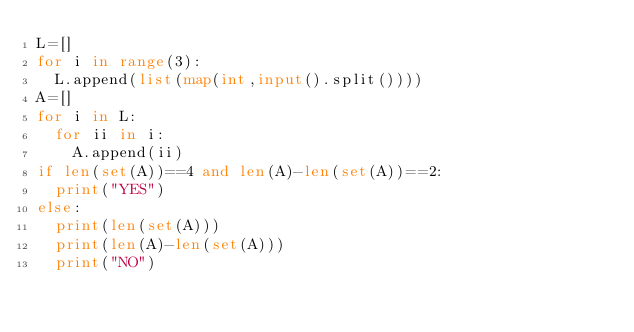Convert code to text. <code><loc_0><loc_0><loc_500><loc_500><_Python_>L=[]
for i in range(3):
  L.append(list(map(int,input().split())))
A=[]
for i in L:
  for ii in i:
    A.append(ii)
if len(set(A))==4 and len(A)-len(set(A))==2:
  print("YES")
else:
  print(len(set(A)))
  print(len(A)-len(set(A)))
  print("NO")</code> 